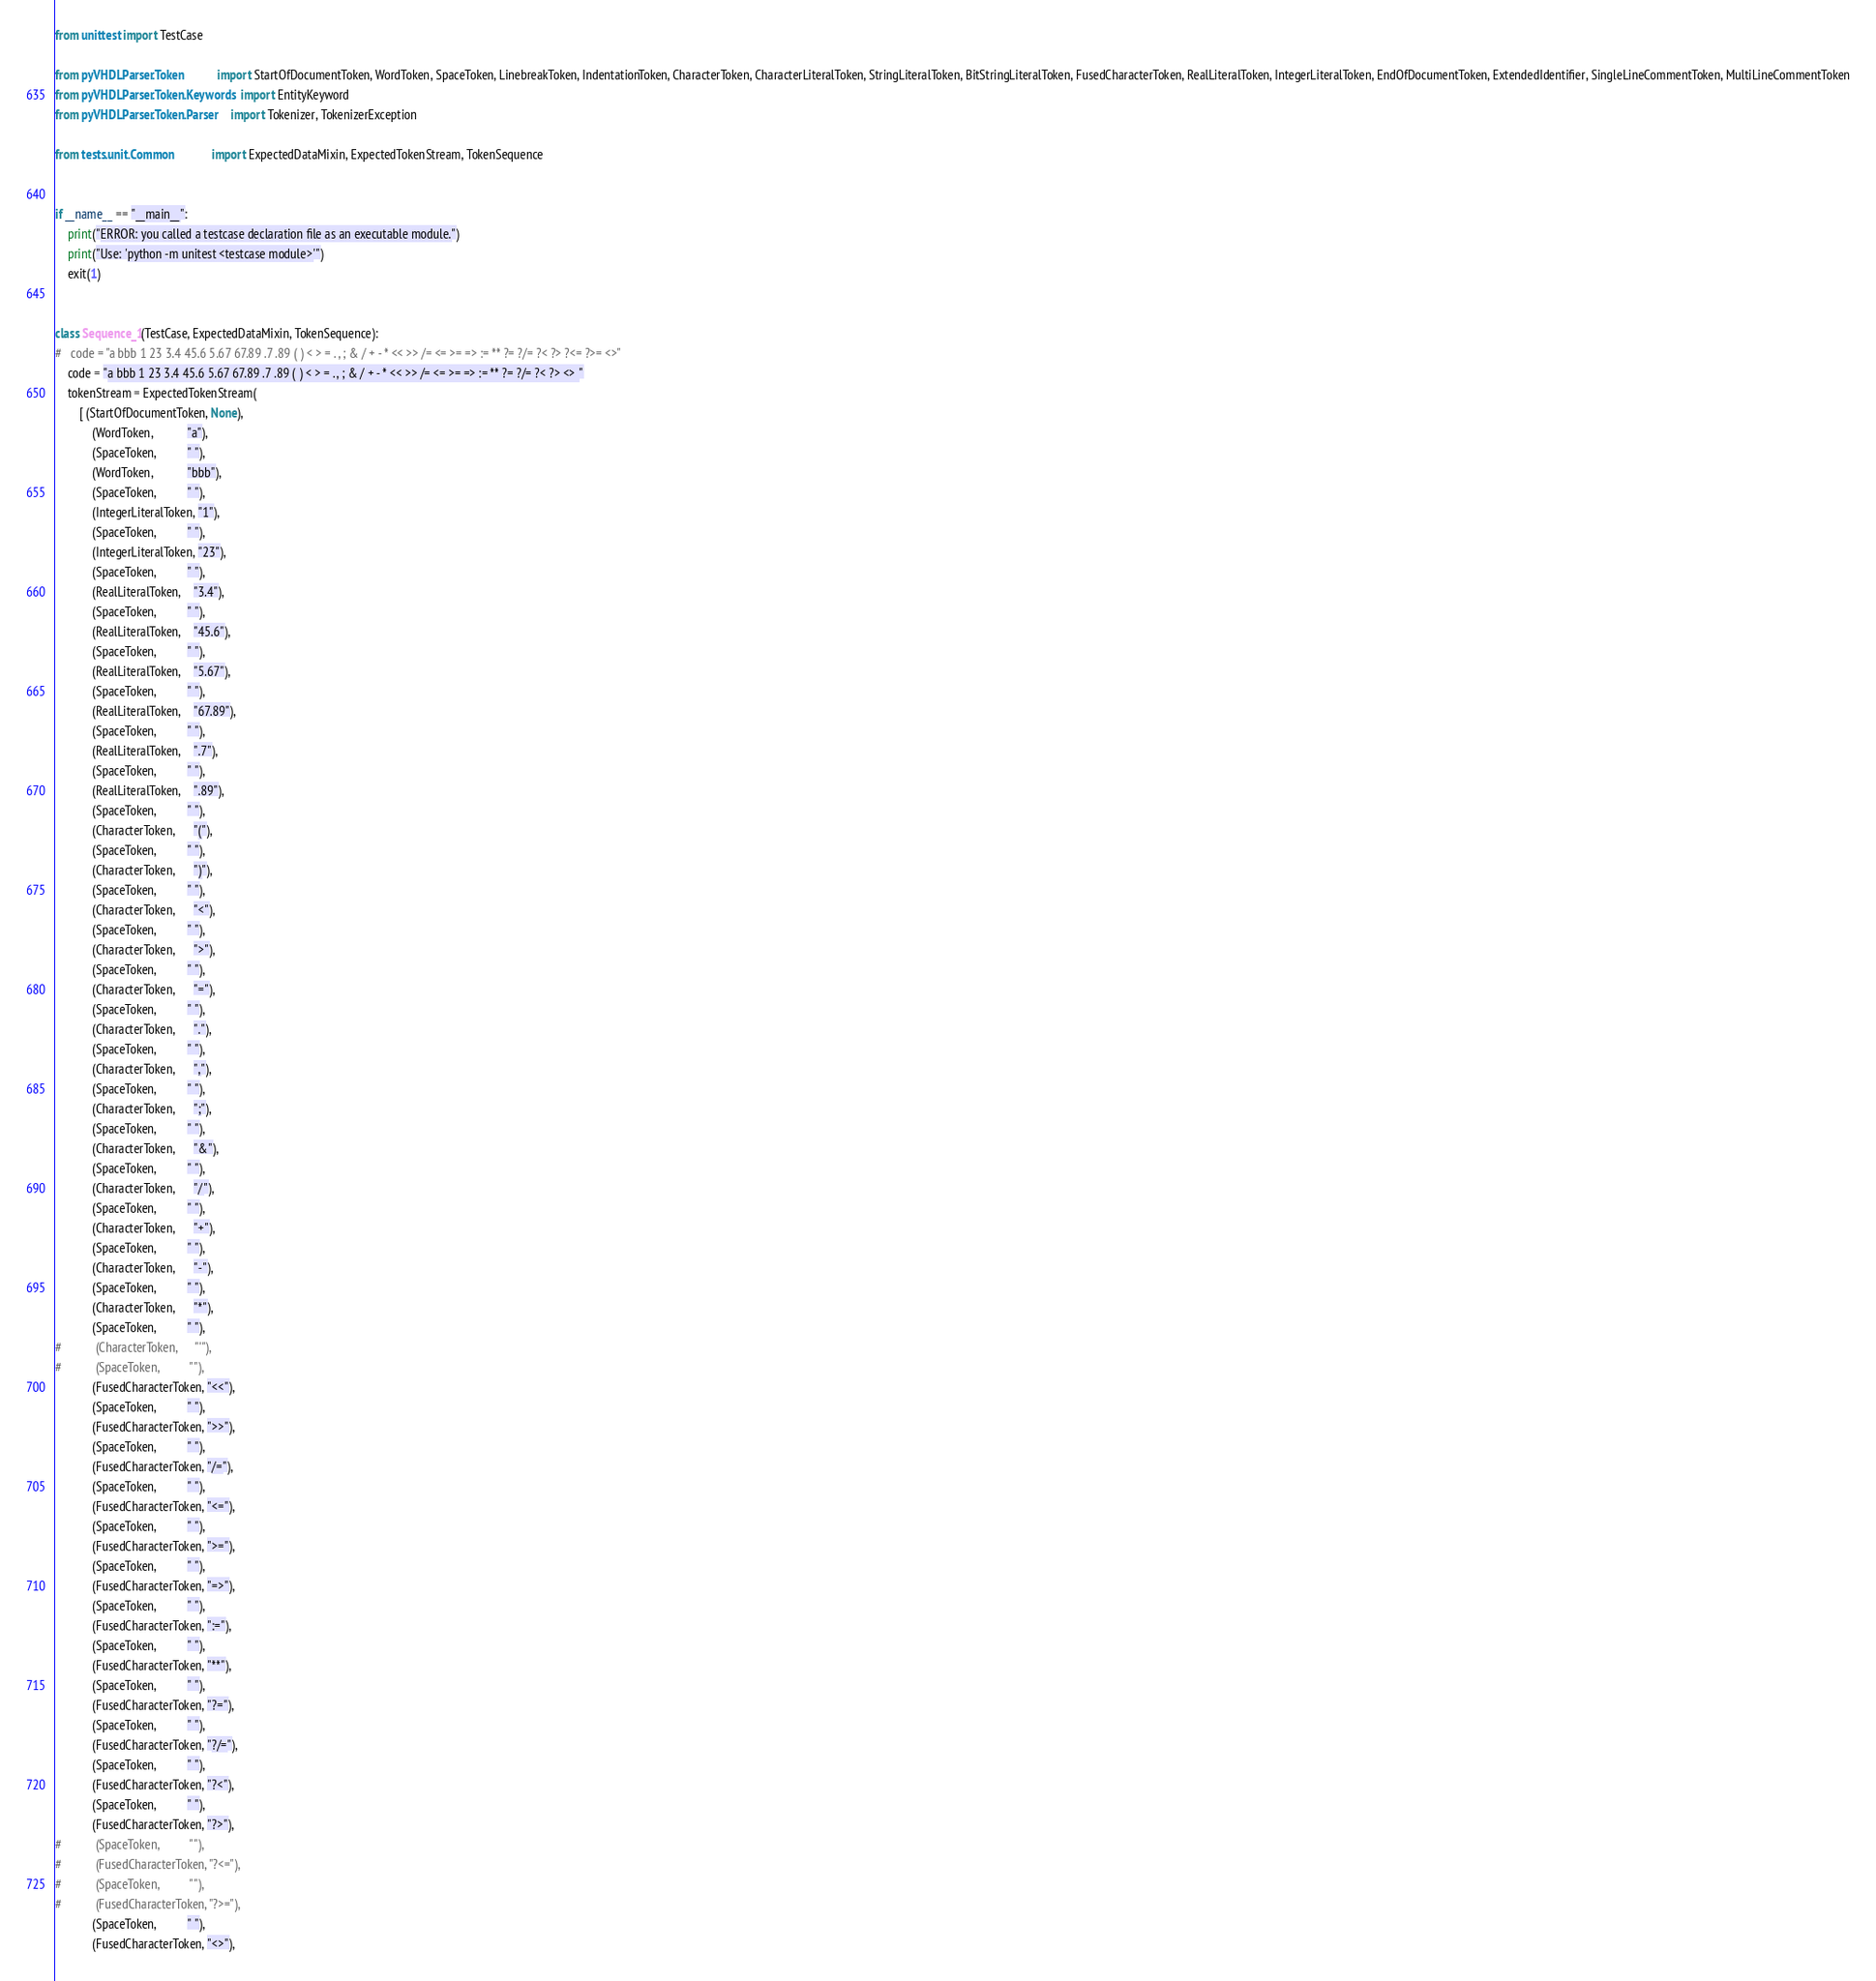Convert code to text. <code><loc_0><loc_0><loc_500><loc_500><_Python_>from unittest import TestCase

from pyVHDLParser.Token           import StartOfDocumentToken, WordToken, SpaceToken, LinebreakToken, IndentationToken, CharacterToken, CharacterLiteralToken, StringLiteralToken, BitStringLiteralToken, FusedCharacterToken, RealLiteralToken, IntegerLiteralToken, EndOfDocumentToken, ExtendedIdentifier, SingleLineCommentToken, MultiLineCommentToken
from pyVHDLParser.Token.Keywords  import EntityKeyword
from pyVHDLParser.Token.Parser    import Tokenizer, TokenizerException

from tests.unit.Common            import ExpectedDataMixin, ExpectedTokenStream, TokenSequence


if __name__ == "__main__":
	print("ERROR: you called a testcase declaration file as an executable module.")
	print("Use: 'python -m unitest <testcase module>'")
	exit(1)


class Sequence_1(TestCase, ExpectedDataMixin, TokenSequence):
#	code = "a bbb 1 23 3.4 45.6 5.67 67.89 .7 .89 ( ) < > = . , ; & / + - * << >> /= <= >= => := ** ?= ?/= ?< ?> ?<= ?>= <>"
	code = "a bbb 1 23 3.4 45.6 5.67 67.89 .7 .89 ( ) < > = . , ; & / + - * << >> /= <= >= => := ** ?= ?/= ?< ?> <> "
	tokenStream = ExpectedTokenStream(
		[ (StartOfDocumentToken, None),
			(WordToken,           "a"),
			(SpaceToken,          " "),
			(WordToken,           "bbb"),
			(SpaceToken,          " "),
			(IntegerLiteralToken, "1"),
			(SpaceToken,          " "),
			(IntegerLiteralToken, "23"),
			(SpaceToken,          " "),
			(RealLiteralToken,    "3.4"),
			(SpaceToken,          " "),
			(RealLiteralToken,    "45.6"),
			(SpaceToken,          " "),
			(RealLiteralToken,    "5.67"),
			(SpaceToken,          " "),
			(RealLiteralToken,    "67.89"),
			(SpaceToken,          " "),
			(RealLiteralToken,    ".7"),
			(SpaceToken,          " "),
			(RealLiteralToken,    ".89"),
			(SpaceToken,          " "),
			(CharacterToken,      "("),
			(SpaceToken,          " "),
			(CharacterToken,      ")"),
			(SpaceToken,          " "),
			(CharacterToken,      "<"),
			(SpaceToken,          " "),
			(CharacterToken,      ">"),
			(SpaceToken,          " "),
			(CharacterToken,      "="),
			(SpaceToken,          " "),
			(CharacterToken,      "."),
			(SpaceToken,          " "),
			(CharacterToken,      ","),
			(SpaceToken,          " "),
			(CharacterToken,      ";"),
			(SpaceToken,          " "),
			(CharacterToken,      "&"),
			(SpaceToken,          " "),
			(CharacterToken,      "/"),
			(SpaceToken,          " "),
			(CharacterToken,      "+"),
			(SpaceToken,          " "),
			(CharacterToken,      "-"),
			(SpaceToken,          " "),
			(CharacterToken,      "*"),
			(SpaceToken,          " "),
#			(CharacterToken,      "'"),
#			(SpaceToken,          " "),
			(FusedCharacterToken, "<<"),
			(SpaceToken,          " "),
			(FusedCharacterToken, ">>"),
			(SpaceToken,          " "),
			(FusedCharacterToken, "/="),
			(SpaceToken,          " "),
			(FusedCharacterToken, "<="),
			(SpaceToken,          " "),
			(FusedCharacterToken, ">="),
			(SpaceToken,          " "),
			(FusedCharacterToken, "=>"),
			(SpaceToken,          " "),
			(FusedCharacterToken, ":="),
			(SpaceToken,          " "),
			(FusedCharacterToken, "**"),
			(SpaceToken,          " "),
			(FusedCharacterToken, "?="),
			(SpaceToken,          " "),
			(FusedCharacterToken, "?/="),
			(SpaceToken,          " "),
			(FusedCharacterToken, "?<"),
			(SpaceToken,          " "),
			(FusedCharacterToken, "?>"),
#			(SpaceToken,          " "),
#			(FusedCharacterToken, "?<="),
#			(SpaceToken,          " "),
#			(FusedCharacterToken, "?>="),
			(SpaceToken,          " "),
			(FusedCharacterToken, "<>"),</code> 